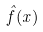<formula> <loc_0><loc_0><loc_500><loc_500>\hat { f } ( x )</formula> 